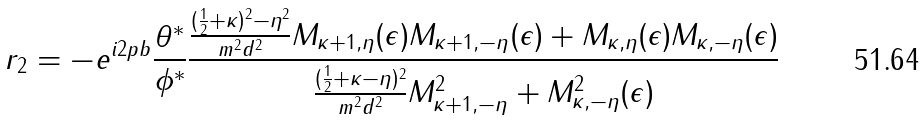<formula> <loc_0><loc_0><loc_500><loc_500>r _ { 2 } = - e ^ { i 2 p b } \frac { \theta ^ { * } } { \phi ^ { * } } \frac { \frac { ( \frac { 1 } { 2 } + \kappa ) ^ { 2 } - \eta ^ { 2 } } { m ^ { 2 } d ^ { 2 } } M _ { \kappa + 1 , \eta } ( \epsilon ) M _ { \kappa + 1 , - \eta } ( \epsilon ) + M _ { \kappa , \eta } ( \epsilon ) M _ { \kappa , - \eta } ( \epsilon ) } { \frac { ( \frac { 1 } { 2 } + \kappa - \eta ) ^ { 2 } } { m ^ { 2 } d ^ { 2 } } M ^ { 2 } _ { \kappa + 1 , - \eta } + M ^ { 2 } _ { \kappa , - \eta } ( \epsilon ) }</formula> 